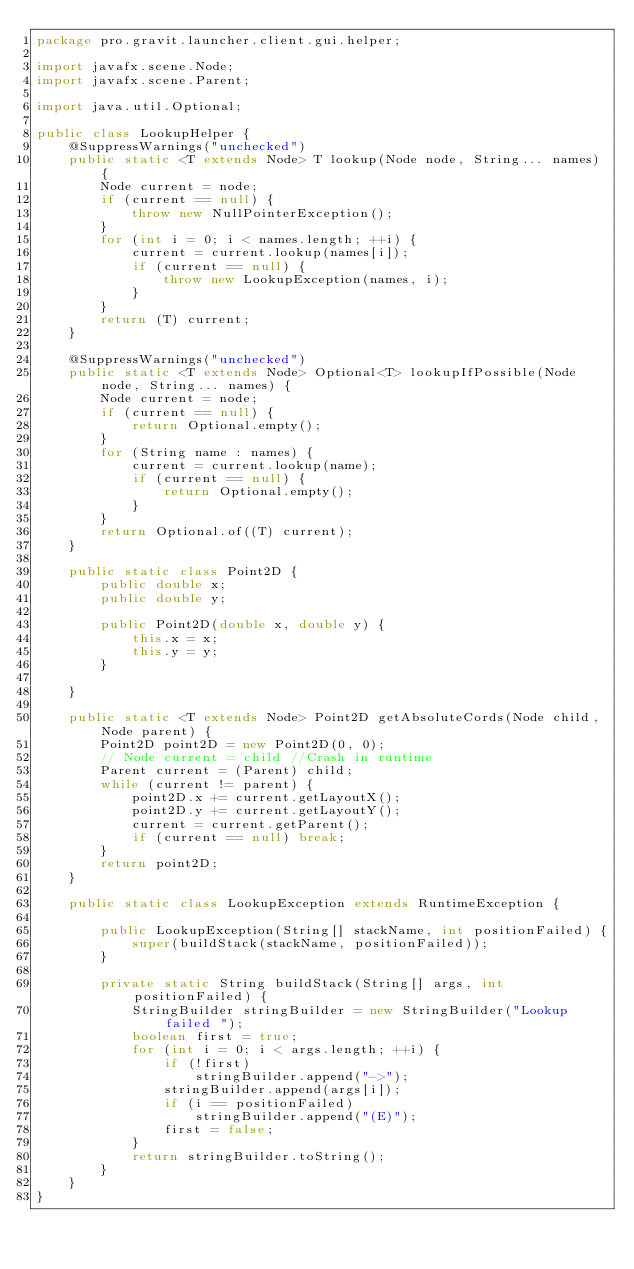Convert code to text. <code><loc_0><loc_0><loc_500><loc_500><_Java_>package pro.gravit.launcher.client.gui.helper;

import javafx.scene.Node;
import javafx.scene.Parent;

import java.util.Optional;

public class LookupHelper {
    @SuppressWarnings("unchecked")
    public static <T extends Node> T lookup(Node node, String... names) {
        Node current = node;
        if (current == null) {
            throw new NullPointerException();
        }
        for (int i = 0; i < names.length; ++i) {
            current = current.lookup(names[i]);
            if (current == null) {
                throw new LookupException(names, i);
            }
        }
        return (T) current;
    }

    @SuppressWarnings("unchecked")
    public static <T extends Node> Optional<T> lookupIfPossible(Node node, String... names) {
        Node current = node;
        if (current == null) {
            return Optional.empty();
        }
        for (String name : names) {
            current = current.lookup(name);
            if (current == null) {
                return Optional.empty();
            }
        }
        return Optional.of((T) current);
    }

    public static class Point2D {
        public double x;
        public double y;

        public Point2D(double x, double y) {
            this.x = x;
            this.y = y;
        }

    }

    public static <T extends Node> Point2D getAbsoluteCords(Node child, Node parent) {
        Point2D point2D = new Point2D(0, 0);
        // Node current = child //Crash in runtime
        Parent current = (Parent) child;
        while (current != parent) {
            point2D.x += current.getLayoutX();
            point2D.y += current.getLayoutY();
            current = current.getParent();
            if (current == null) break;
        }
        return point2D;
    }

    public static class LookupException extends RuntimeException {

        public LookupException(String[] stackName, int positionFailed) {
            super(buildStack(stackName, positionFailed));
        }

        private static String buildStack(String[] args, int positionFailed) {
            StringBuilder stringBuilder = new StringBuilder("Lookup failed ");
            boolean first = true;
            for (int i = 0; i < args.length; ++i) {
                if (!first)
                    stringBuilder.append("->");
                stringBuilder.append(args[i]);
                if (i == positionFailed)
                    stringBuilder.append("(E)");
                first = false;
            }
            return stringBuilder.toString();
        }
    }
}
</code> 